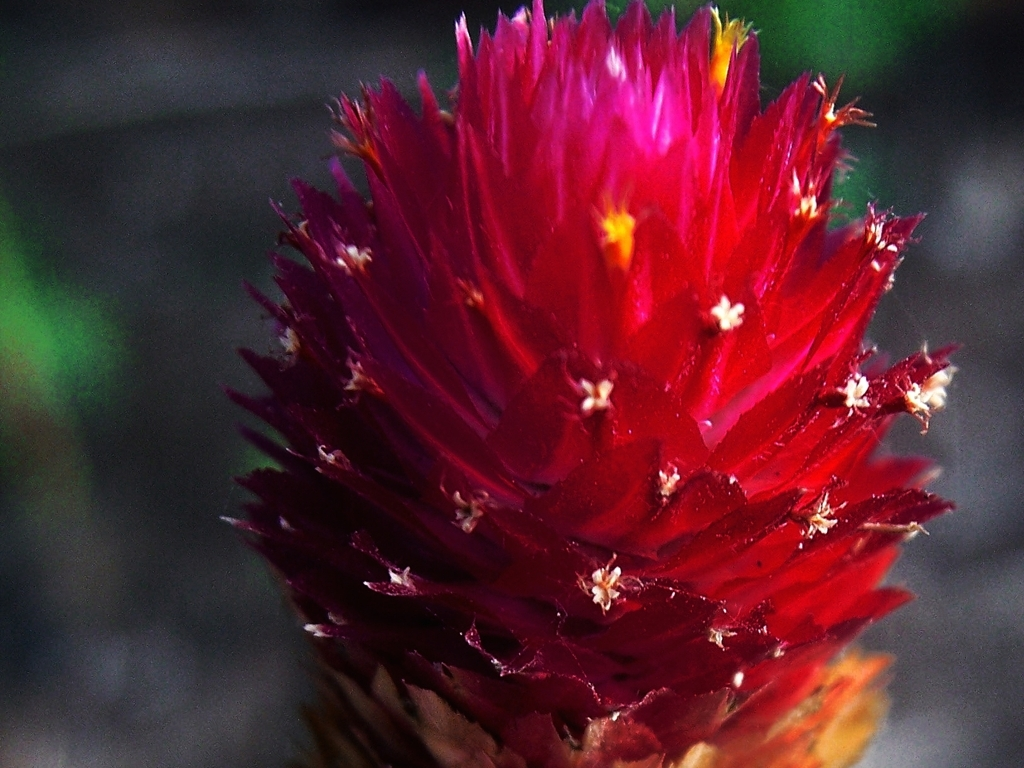How does the texture of the flower contribute to the overall impression of the image? The texture of the flower, with its fine details and sharp contrasts between the petals and the softer-looking surrounding elements, adds a tangible depth and dynamic quality to the image, enhancing its visual appeal. 